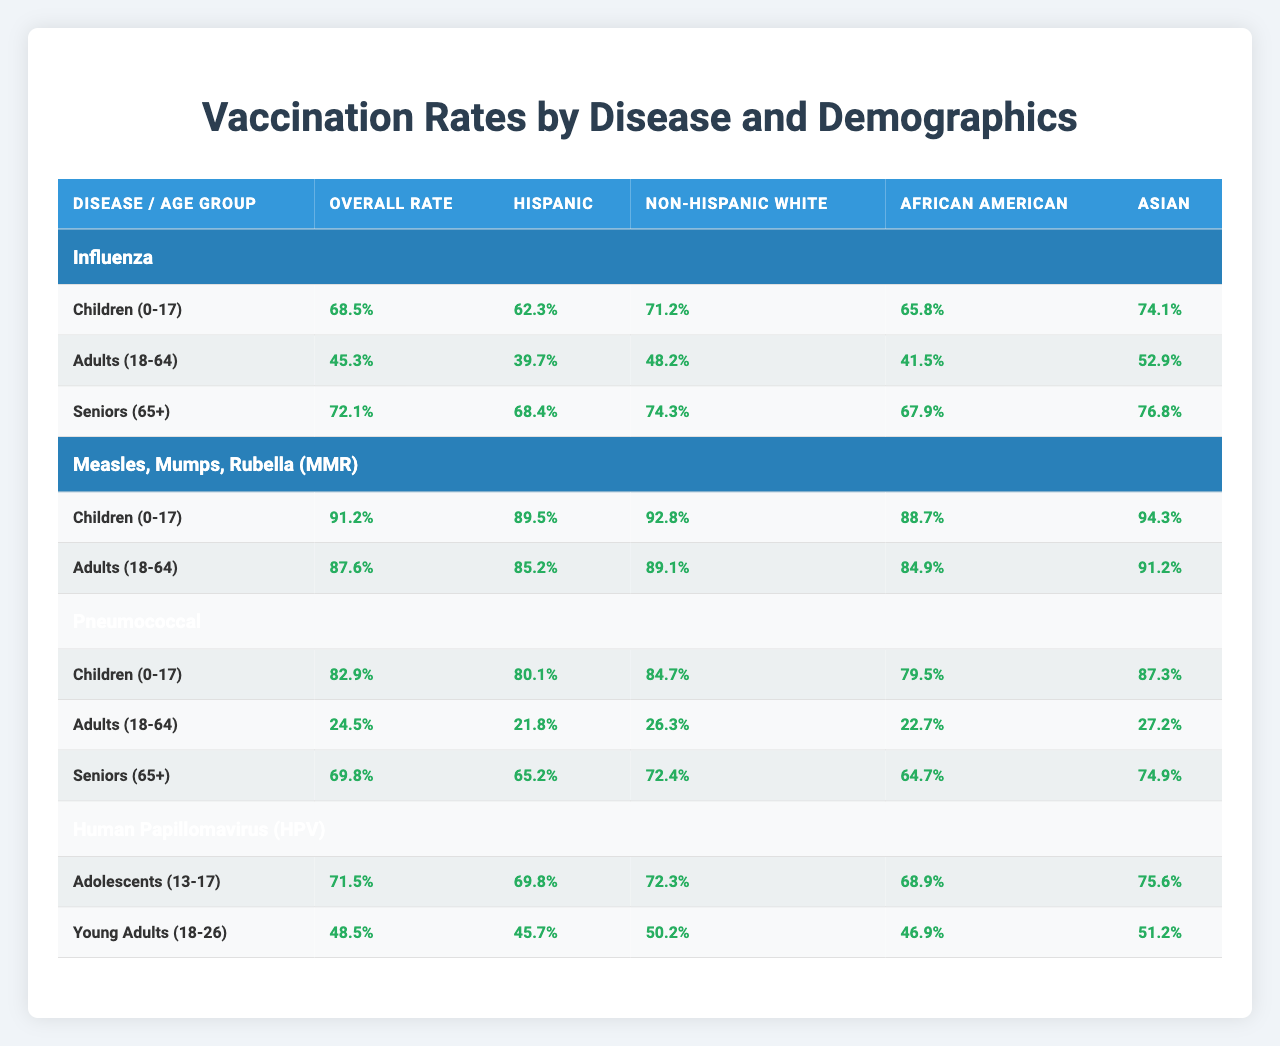What is the vaccination rate for influenza among seniors (65+)? The table shows that the vaccination rate for influenza among seniors (65+) is 72.1%.
Answer: 72.1% Which age group has the highest vaccination rate for Measles, Mumps, Rubella (MMR)? The highest vaccination rate for MMR is among children (0-17), which is 91.2%.
Answer: Children (0-17) What is the difference in the overall vaccination rate for pneumococcal disease between children (0-17) and adults (18-64)? The overall vaccination rate for children (0-17) is 82.9% and for adults (18-64) is 24.5%. The difference is 82.9 - 24.5 = 58.4%.
Answer: 58.4% True or False: The vaccination rate for Hispanic individuals in the Adults (18-64) group for Influenza is higher than that for Asian individuals. The vaccination rate for Hispanic individuals is 39.7%, while for Asian individuals, it is 52.9%. Therefore, the statement is false.
Answer: False What is the average vaccination rate for Hispanic individuals across all diseases among children (0-17)? The rates for Hispanic children (0-17) in three diseases are: Influenza (62.3%), MMR (89.5%), and Pneumococcal (80.1%). Adding them gives 62.3 + 89.5 + 80.1 = 231.9%. Dividing by 3 gives an average of 231.9 / 3 = 77.3%.
Answer: 77.3% Which disease has the lowest vaccination rate for adults (18-64) among Non-Hispanic White individuals? The lowest vaccination rate for adults (18-64) among Non-Hispanic White individuals is for Pneumococcal, which is 26.3%.
Answer: Pneumococcal What is the range of vaccination rates for the Asian demographic across all diseases in the seniors (65+) age group? In the seniors (65+) age group, the vaccination rates for Asian individuals are: Influenza (76.8%), Pneumococcal (74.9%). The range is 76.8% - 74.9% = 1.9%.
Answer: 1.9% Among the ethnicities listed, which has the highest vaccination rate for adolescents (13-17) for HPV? Among adolescents (13-17) for HPV, the highest vaccination rate is for Asian individuals at 75.6%.
Answer: Asian What percentage of adults (18-64) are vaccinated against influenza and how does this compare to those vaccinated against pneumococcal? The vaccination rate for influenza in adults (18-64) is 45.3% and for pneumococcal is 24.5%. So, 45.3 - 24.5 = 20.8% more adults are vaccinated against influenza.
Answer: 20.8% What is the total percentage of Hispanic individuals vaccinated among the three age groups for pneumococcal disease? The rates for Hispanic individuals are: Children (0-17) 80.1%, Adults (18-64) 21.8%, and Seniors (65+) 65.2%. Adding these gives 80.1 + 21.8 + 65.2 = 167.1%.
Answer: 167.1% 